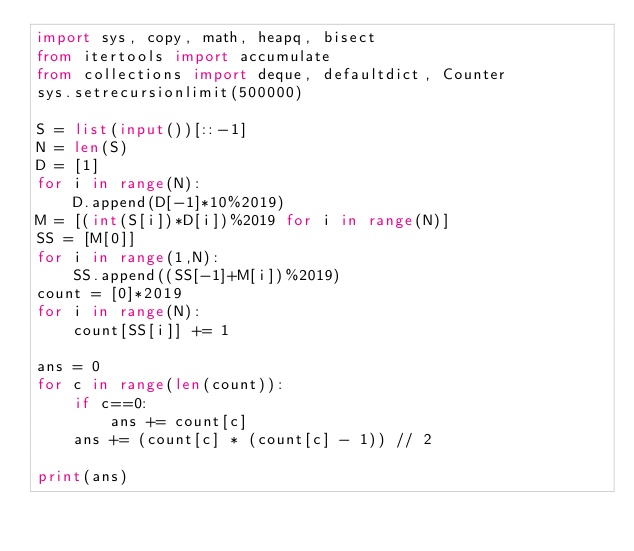<code> <loc_0><loc_0><loc_500><loc_500><_Python_>import sys, copy, math, heapq, bisect
from itertools import accumulate
from collections import deque, defaultdict, Counter
sys.setrecursionlimit(500000)

S = list(input())[::-1]
N = len(S)
D = [1]
for i in range(N):
    D.append(D[-1]*10%2019)
M = [(int(S[i])*D[i])%2019 for i in range(N)]
SS = [M[0]]
for i in range(1,N):
    SS.append((SS[-1]+M[i])%2019)
count = [0]*2019
for i in range(N):
    count[SS[i]] += 1

ans = 0
for c in range(len(count)):
    if c==0:
        ans += count[c]
    ans += (count[c] * (count[c] - 1)) // 2

print(ans)
</code> 